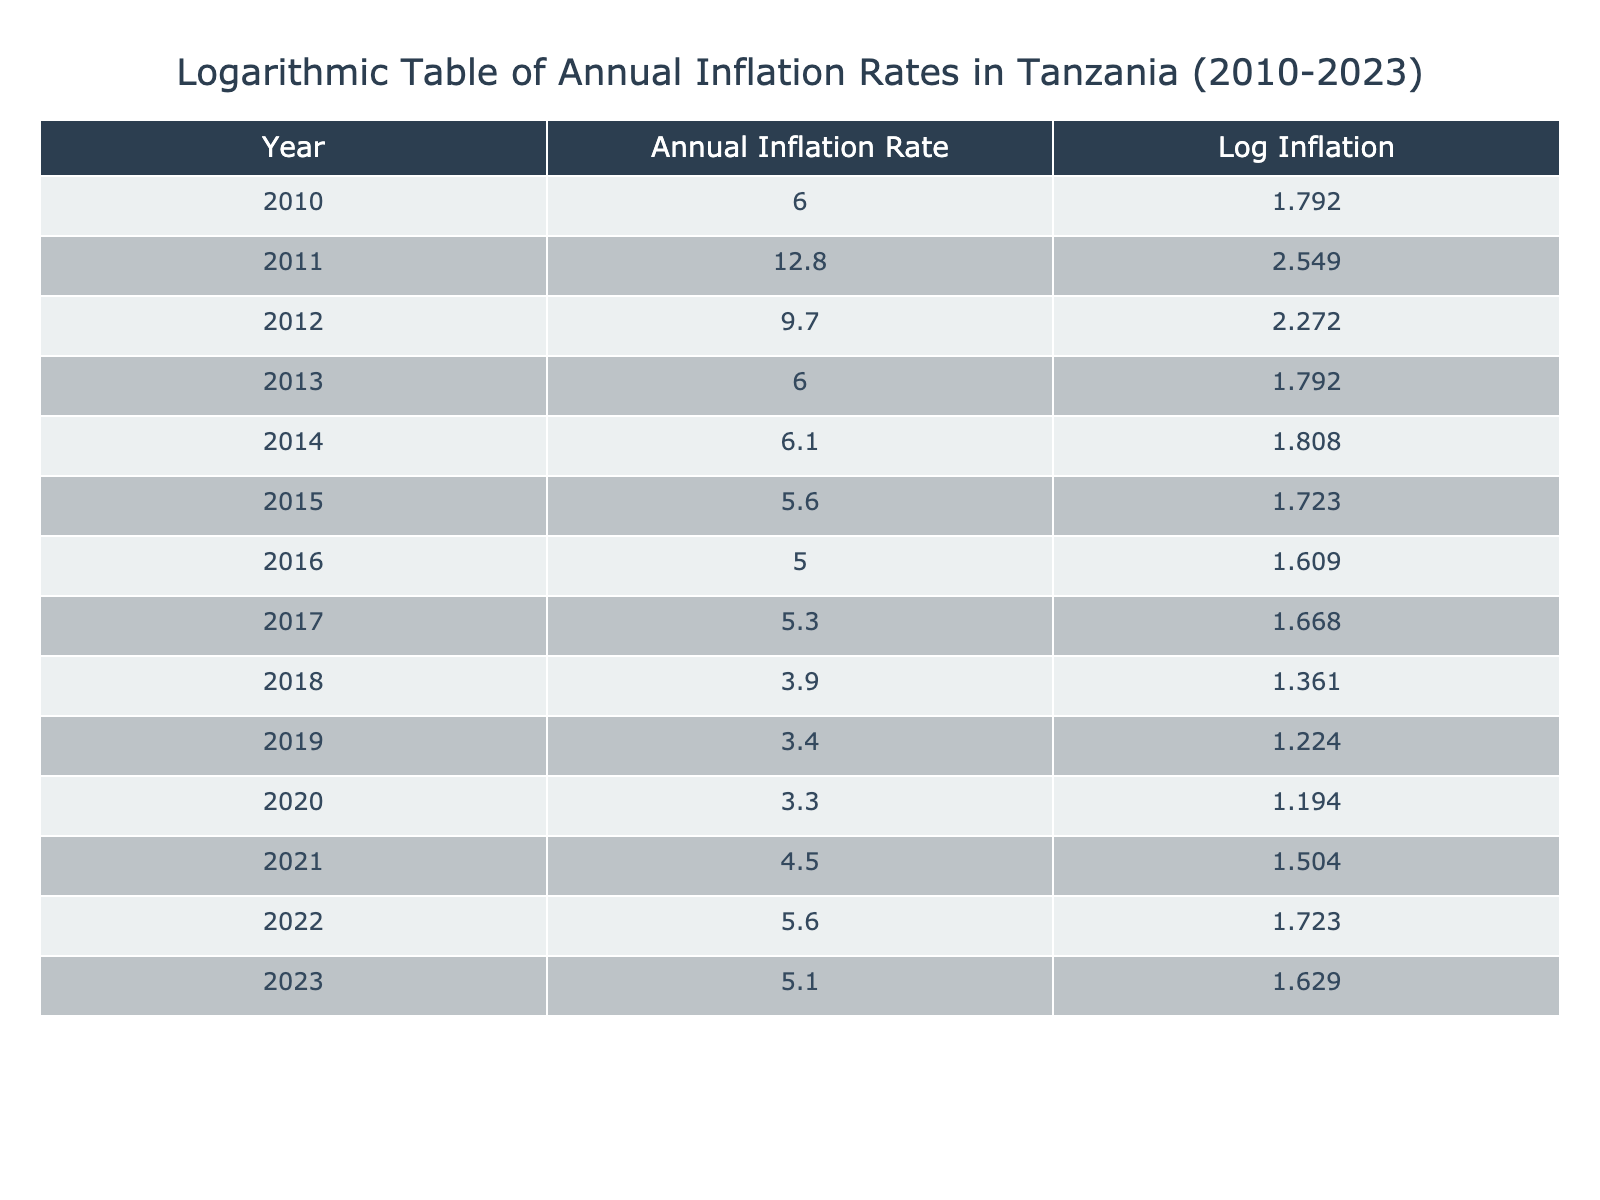What was the highest annual inflation rate recorded between 2010 and 2023? The highest annual inflation rate in the table is found by looking through the values in the "Annual Inflation Rate" column. The highest value is 12.8, which corresponds to the year 2011.
Answer: 12.8 In which year did the annual inflation rate first drop below 4%? By examining the "Annual Inflation Rate" column, I can see that the rate dropped below 4% in 2019 when it was 3.4.
Answer: 2019 What is the average annual inflation rate between 2010 and 2023? To calculate the average, I add all the annual inflation rates together: (6.0 + 12.8 + 9.7 + 6.0 + 6.1 + 5.6 + 5.0 + 5.3 + 3.9 + 3.4 + 3.3 + 4.5 + 5.6 + 5.1) =  73.3. Since there are 14 years, the average is 73.3/14 = 5.21.
Answer: 5.21 Was the annual inflation rate in 2021 higher than in 2022? By directly comparing the values in the "Annual Inflation Rate" for the years 2021 (4.5) and 2022 (5.6), I can see that 4.5 is indeed lower than 5.6. Therefore, the statement is false.
Answer: No What was the change in the annual inflation rate from 2010 to 2023? Firstly, the annual inflation rate in 2010 was 6.0, and for 2023 it was 5.1. The change is calculated as 5.1 - 6.0 = -0.9, indicating a decrease over the period.
Answer: -0.9 Which year had the lowest annual inflation rate and what was that rate? By reviewing the column "Annual Inflation Rate", the lowest value can be found. It's 3.3 in the year 2020.
Answer: 3.3 in 2020 How many years recorded an annual inflation rate above 6%? By counting all the values in the "Annual Inflation Rate" column that exceed 6%, I find that there are 3 such years: 2011 (12.8), 2012 (9.7), and 2014 (6.1).
Answer: 3 What was the logarithmic inflation rate for the year with the highest annual inflation? The highest annual inflation was in 2011 with a rate of 12.8. The logarithm of 12.8 is approximately 2.558 (using log base "e").
Answer: 2.558 